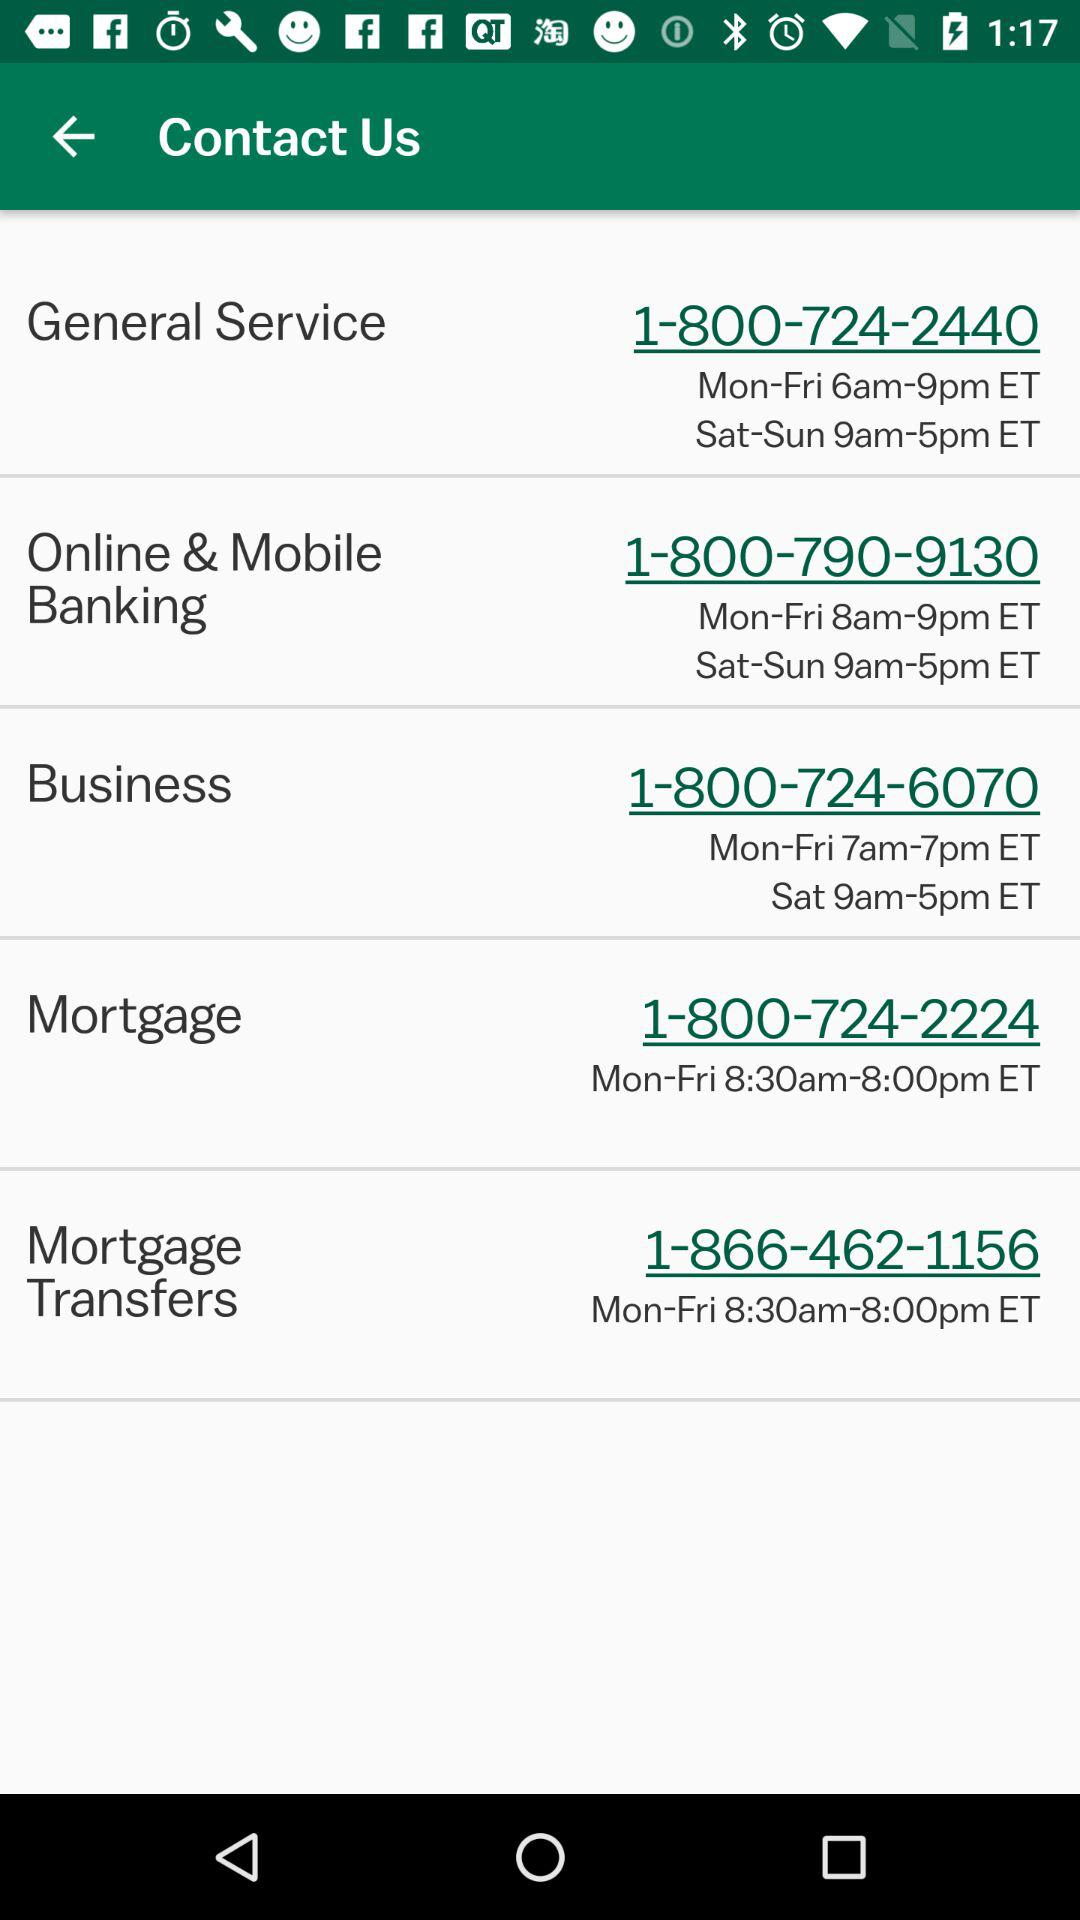What is the time to talk to "General Service" between Monday to Friday? The time is 6am-9pm ET. 